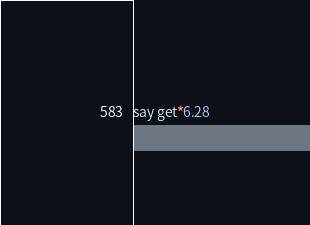<code> <loc_0><loc_0><loc_500><loc_500><_Perl_>say get*6.28</code> 